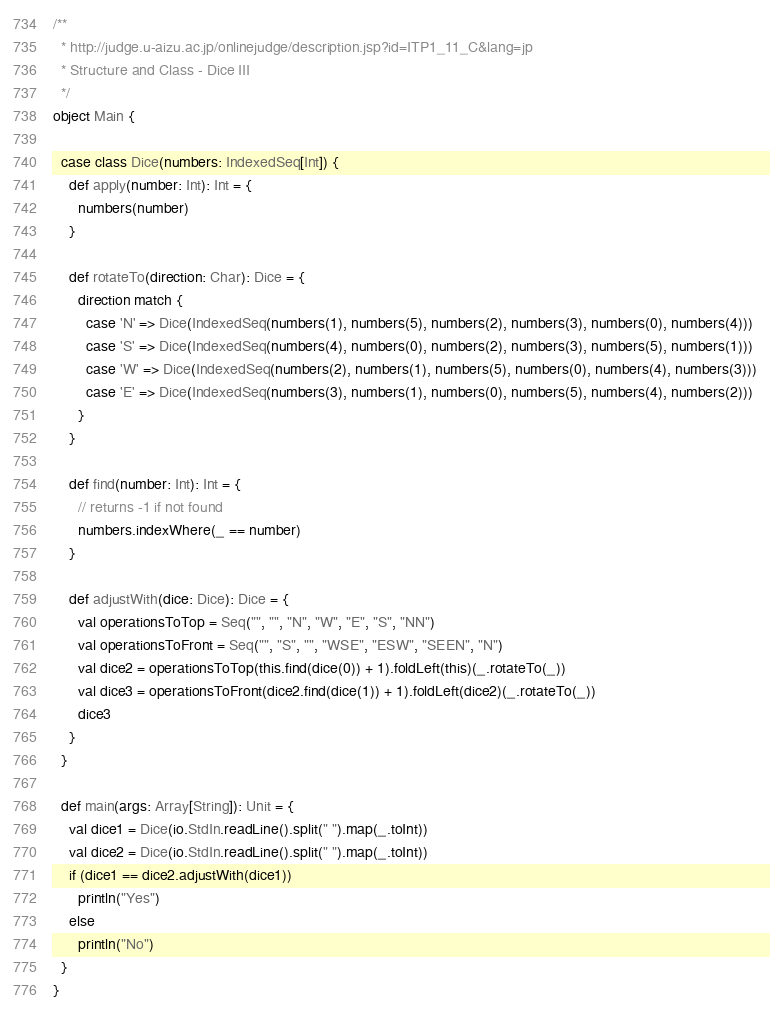Convert code to text. <code><loc_0><loc_0><loc_500><loc_500><_Scala_>/**
  * http://judge.u-aizu.ac.jp/onlinejudge/description.jsp?id=ITP1_11_C&lang=jp
  * Structure and Class - Dice III
  */
object Main {

  case class Dice(numbers: IndexedSeq[Int]) {
    def apply(number: Int): Int = {
      numbers(number)
    }

    def rotateTo(direction: Char): Dice = {
      direction match {
        case 'N' => Dice(IndexedSeq(numbers(1), numbers(5), numbers(2), numbers(3), numbers(0), numbers(4)))
        case 'S' => Dice(IndexedSeq(numbers(4), numbers(0), numbers(2), numbers(3), numbers(5), numbers(1)))
        case 'W' => Dice(IndexedSeq(numbers(2), numbers(1), numbers(5), numbers(0), numbers(4), numbers(3)))
        case 'E' => Dice(IndexedSeq(numbers(3), numbers(1), numbers(0), numbers(5), numbers(4), numbers(2)))
      }
    }

    def find(number: Int): Int = {
      // returns -1 if not found
      numbers.indexWhere(_ == number)
    }

    def adjustWith(dice: Dice): Dice = {
      val operationsToTop = Seq("", "", "N", "W", "E", "S", "NN")
      val operationsToFront = Seq("", "S", "", "WSE", "ESW", "SEEN", "N")
      val dice2 = operationsToTop(this.find(dice(0)) + 1).foldLeft(this)(_.rotateTo(_))
      val dice3 = operationsToFront(dice2.find(dice(1)) + 1).foldLeft(dice2)(_.rotateTo(_))
      dice3
    }
  }

  def main(args: Array[String]): Unit = {
    val dice1 = Dice(io.StdIn.readLine().split(" ").map(_.toInt))
    val dice2 = Dice(io.StdIn.readLine().split(" ").map(_.toInt))
    if (dice1 == dice2.adjustWith(dice1))
      println("Yes")
    else
      println("No")
  }
}</code> 